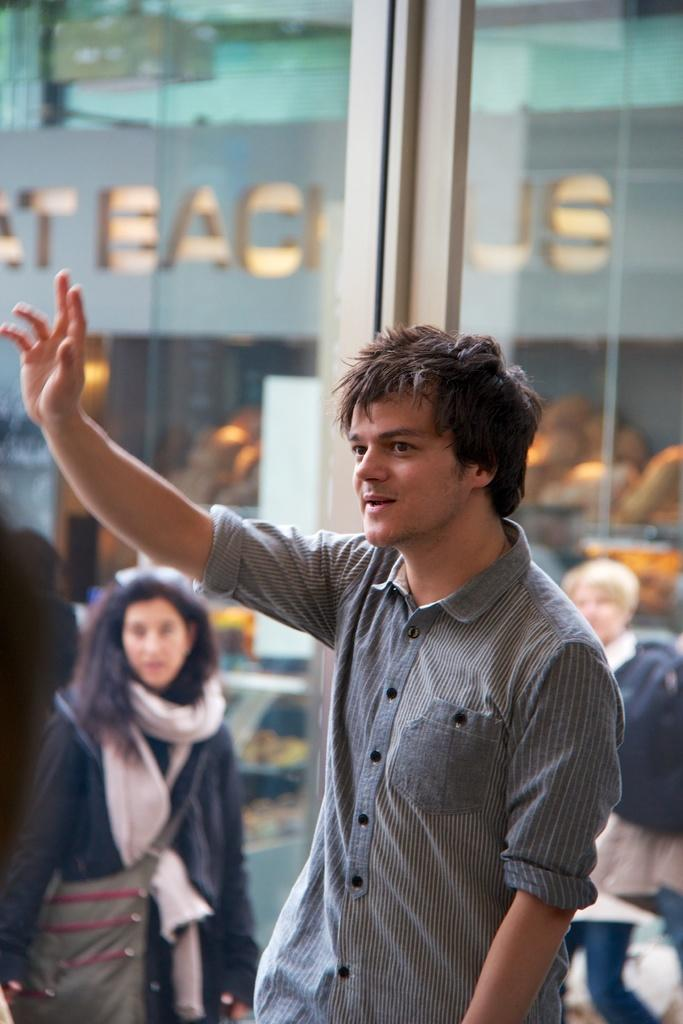What is the main subject of the image? There is a person in the image. What is the person wearing? The person is wearing a shirt. What is the person doing with their hand? The person is showing a hand. What is the person's posture in the image? The person is standing. Can you describe the background of the image? There are other persons, a hoarding, a wall, and other objects in the background of the image. What decision did the person make regarding the company in the image? There is no information about a company or any decision-making in the image. The image only shows a person standing and showing a hand, along with a background that includes other persons, a hoarding, a wall, and other objects. 